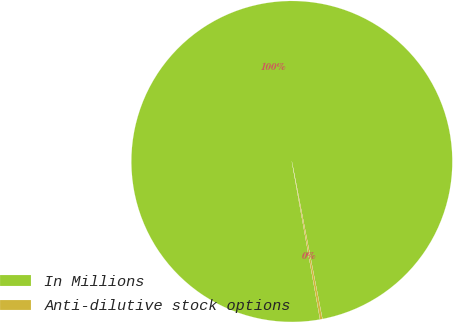<chart> <loc_0><loc_0><loc_500><loc_500><pie_chart><fcel>In Millions<fcel>Anti-dilutive stock options<nl><fcel>99.76%<fcel>0.24%<nl></chart> 